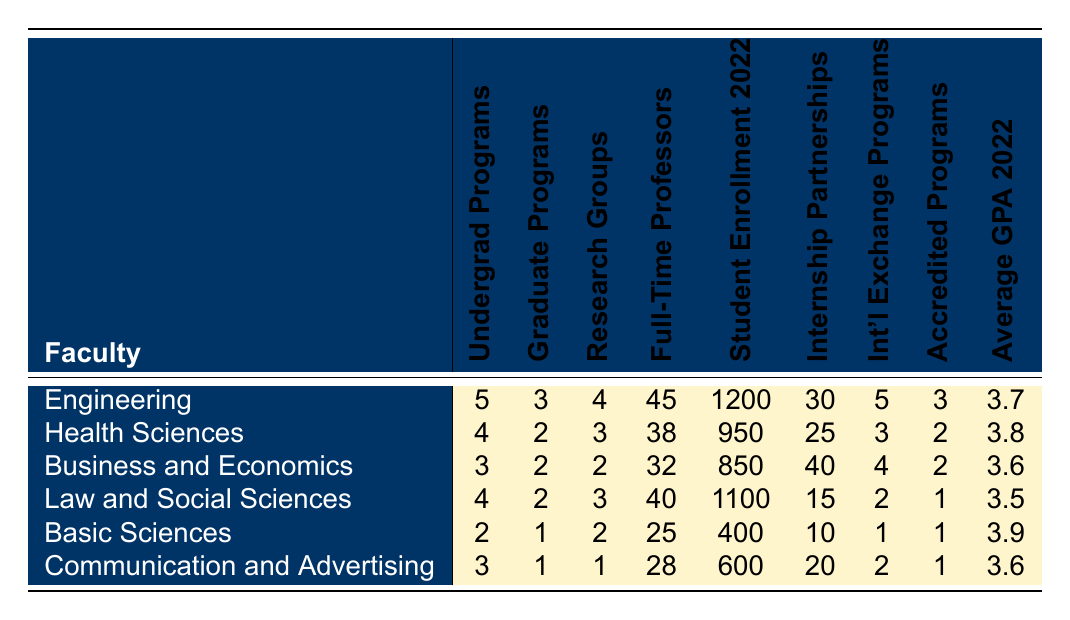What faculty has the highest number of undergraduate programs? Looking at the "Undergraduate Programs" column, Engineering has the highest number at 5 programs compared to the other faculties.
Answer: Engineering What is the total number of research groups across all faculties? To find the total, sum all values in the "Research Groups" column: 4 + 3 + 2 + 3 + 2 + 1 = 15.
Answer: 15 Which faculty has the lowest student enrollment in 2022? The "Student Enrollment 2022" column shows Basic Sciences with the lowest enrollment of 400 students compared to other faculties.
Answer: Basic Sciences Is there a faculty with more than 30 internship partnerships? By checking the "Internship Partnerships" column, Business and Economics has 40 partnerships, which is more than 30.
Answer: Yes What is the average GPA for the faculties with graduate programs? First, identify faculties with graduate programs (Engineering, Health Sciences, Business and Economics, Law, Basic Sciences, and Communication) and calculate their average GPA: (3.7 + 3.8 + 3.6 + 3.5 + 3.9 + 3.6) / 6 = 3.65.
Answer: 3.65 Which faculty has the most full-time professors, and what is that number? The "Full-Time Professors" column indicates Engineering has the most with 45 professors.
Answer: Engineering, 45 What is the difference in the number of undergraduate programs between Health Sciences and Basic Sciences? Subtract the number of undergraduate programs in Basic Sciences (2) from Health Sciences (4): 4 - 2 = 2.
Answer: 2 Are there any faculties with an average GPA above 3.8? By examining the "Average GPA 2022" column, only Health Sciences has an average GPA of 3.8, which is above that threshold.
Answer: Yes What is the total number of accredited programs offered by all faculties? To determine this, sum all values in the "Accredited Programs" column: 3 + 2 + 2 + 1 + 1 + 1 = 10.
Answer: 10 Which faculty has the fewest graduate programs, and what is that number? The "Graduate Programs" column shows Basic Sciences with the fewest at 1 graduate program.
Answer: Basic Sciences, 1 